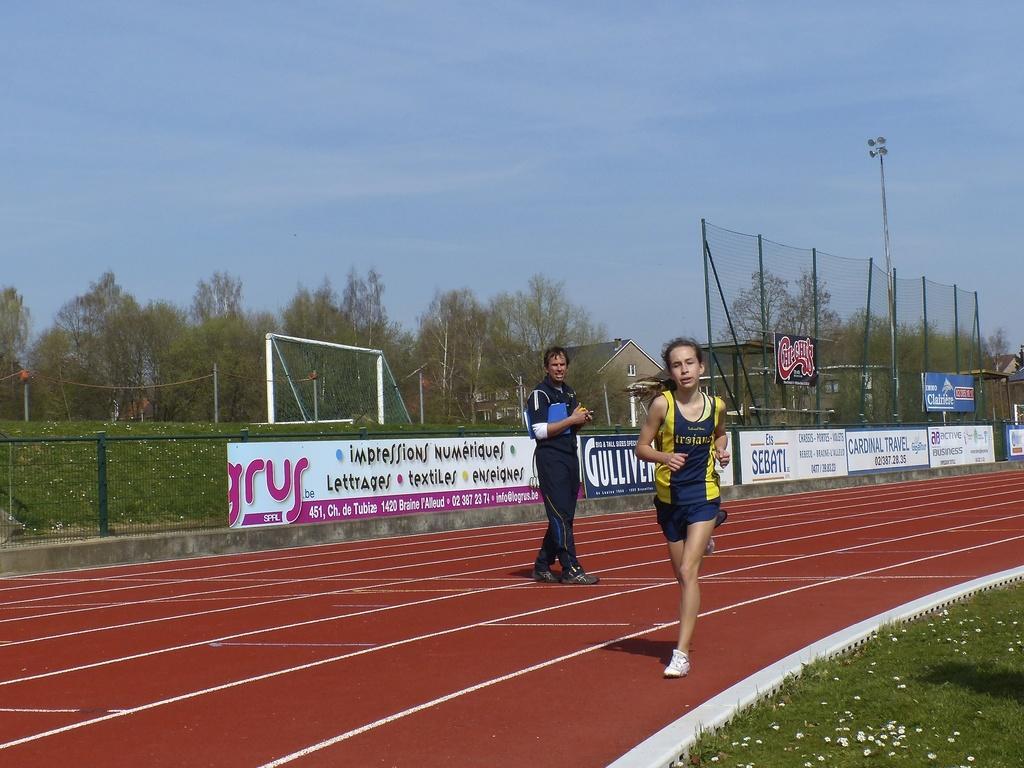Describe this image in one or two sentences. In this image, I can see a woman running and a person standing. There are hoardings to the fence, a building, football goal post, grass and the trees behind a person. At the bottom right side of the image, I can see the grass with the tiny flowers. In the background, there is the sky. 